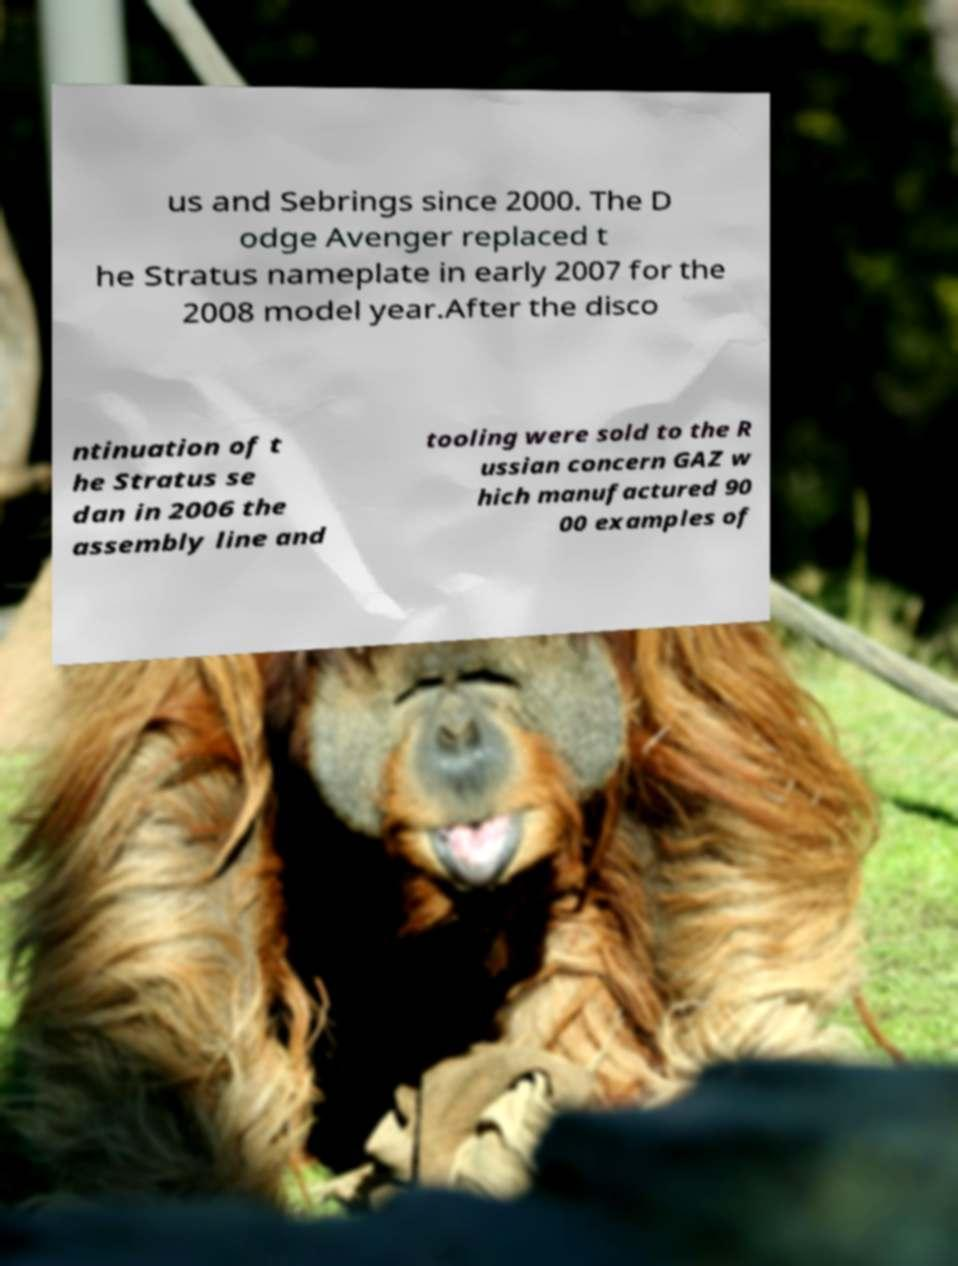Could you extract and type out the text from this image? us and Sebrings since 2000. The D odge Avenger replaced t he Stratus nameplate in early 2007 for the 2008 model year.After the disco ntinuation of t he Stratus se dan in 2006 the assembly line and tooling were sold to the R ussian concern GAZ w hich manufactured 90 00 examples of 